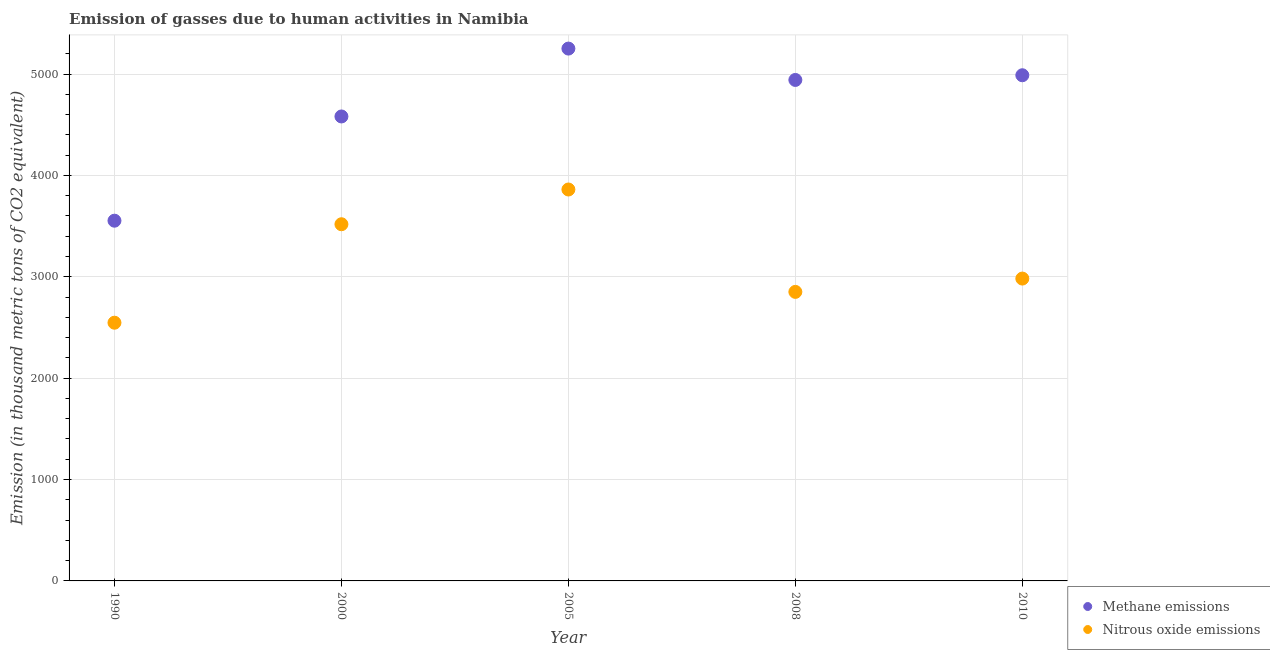How many different coloured dotlines are there?
Your response must be concise. 2. Is the number of dotlines equal to the number of legend labels?
Keep it short and to the point. Yes. What is the amount of nitrous oxide emissions in 2008?
Provide a succinct answer. 2851.2. Across all years, what is the maximum amount of methane emissions?
Your answer should be compact. 5251.3. Across all years, what is the minimum amount of methane emissions?
Offer a very short reply. 3553.5. In which year was the amount of nitrous oxide emissions maximum?
Provide a succinct answer. 2005. In which year was the amount of methane emissions minimum?
Provide a succinct answer. 1990. What is the total amount of methane emissions in the graph?
Give a very brief answer. 2.33e+04. What is the difference between the amount of nitrous oxide emissions in 1990 and that in 2000?
Ensure brevity in your answer.  -971.4. What is the difference between the amount of nitrous oxide emissions in 2000 and the amount of methane emissions in 2005?
Offer a very short reply. -1732.8. What is the average amount of methane emissions per year?
Make the answer very short. 4663.32. In the year 2008, what is the difference between the amount of nitrous oxide emissions and amount of methane emissions?
Offer a terse response. -2090.7. In how many years, is the amount of nitrous oxide emissions greater than 4600 thousand metric tons?
Ensure brevity in your answer.  0. What is the ratio of the amount of methane emissions in 2000 to that in 2008?
Your response must be concise. 0.93. What is the difference between the highest and the second highest amount of methane emissions?
Provide a succinct answer. 263.1. What is the difference between the highest and the lowest amount of nitrous oxide emissions?
Provide a succinct answer. 1314.1. Does the amount of nitrous oxide emissions monotonically increase over the years?
Your response must be concise. No. Is the amount of methane emissions strictly greater than the amount of nitrous oxide emissions over the years?
Make the answer very short. Yes. Is the amount of methane emissions strictly less than the amount of nitrous oxide emissions over the years?
Offer a very short reply. No. How many years are there in the graph?
Keep it short and to the point. 5. Are the values on the major ticks of Y-axis written in scientific E-notation?
Your answer should be compact. No. Does the graph contain any zero values?
Give a very brief answer. No. How many legend labels are there?
Offer a terse response. 2. How are the legend labels stacked?
Keep it short and to the point. Vertical. What is the title of the graph?
Provide a succinct answer. Emission of gasses due to human activities in Namibia. Does "Investments" appear as one of the legend labels in the graph?
Provide a short and direct response. No. What is the label or title of the X-axis?
Give a very brief answer. Year. What is the label or title of the Y-axis?
Ensure brevity in your answer.  Emission (in thousand metric tons of CO2 equivalent). What is the Emission (in thousand metric tons of CO2 equivalent) of Methane emissions in 1990?
Offer a very short reply. 3553.5. What is the Emission (in thousand metric tons of CO2 equivalent) in Nitrous oxide emissions in 1990?
Your answer should be very brief. 2547.1. What is the Emission (in thousand metric tons of CO2 equivalent) of Methane emissions in 2000?
Provide a succinct answer. 4581.7. What is the Emission (in thousand metric tons of CO2 equivalent) of Nitrous oxide emissions in 2000?
Give a very brief answer. 3518.5. What is the Emission (in thousand metric tons of CO2 equivalent) in Methane emissions in 2005?
Keep it short and to the point. 5251.3. What is the Emission (in thousand metric tons of CO2 equivalent) in Nitrous oxide emissions in 2005?
Your response must be concise. 3861.2. What is the Emission (in thousand metric tons of CO2 equivalent) of Methane emissions in 2008?
Offer a terse response. 4941.9. What is the Emission (in thousand metric tons of CO2 equivalent) in Nitrous oxide emissions in 2008?
Provide a short and direct response. 2851.2. What is the Emission (in thousand metric tons of CO2 equivalent) of Methane emissions in 2010?
Your response must be concise. 4988.2. What is the Emission (in thousand metric tons of CO2 equivalent) in Nitrous oxide emissions in 2010?
Your answer should be compact. 2982.6. Across all years, what is the maximum Emission (in thousand metric tons of CO2 equivalent) of Methane emissions?
Keep it short and to the point. 5251.3. Across all years, what is the maximum Emission (in thousand metric tons of CO2 equivalent) in Nitrous oxide emissions?
Your answer should be compact. 3861.2. Across all years, what is the minimum Emission (in thousand metric tons of CO2 equivalent) in Methane emissions?
Keep it short and to the point. 3553.5. Across all years, what is the minimum Emission (in thousand metric tons of CO2 equivalent) of Nitrous oxide emissions?
Offer a very short reply. 2547.1. What is the total Emission (in thousand metric tons of CO2 equivalent) of Methane emissions in the graph?
Your answer should be compact. 2.33e+04. What is the total Emission (in thousand metric tons of CO2 equivalent) of Nitrous oxide emissions in the graph?
Offer a terse response. 1.58e+04. What is the difference between the Emission (in thousand metric tons of CO2 equivalent) of Methane emissions in 1990 and that in 2000?
Provide a short and direct response. -1028.2. What is the difference between the Emission (in thousand metric tons of CO2 equivalent) of Nitrous oxide emissions in 1990 and that in 2000?
Provide a short and direct response. -971.4. What is the difference between the Emission (in thousand metric tons of CO2 equivalent) of Methane emissions in 1990 and that in 2005?
Make the answer very short. -1697.8. What is the difference between the Emission (in thousand metric tons of CO2 equivalent) of Nitrous oxide emissions in 1990 and that in 2005?
Offer a terse response. -1314.1. What is the difference between the Emission (in thousand metric tons of CO2 equivalent) of Methane emissions in 1990 and that in 2008?
Give a very brief answer. -1388.4. What is the difference between the Emission (in thousand metric tons of CO2 equivalent) in Nitrous oxide emissions in 1990 and that in 2008?
Make the answer very short. -304.1. What is the difference between the Emission (in thousand metric tons of CO2 equivalent) of Methane emissions in 1990 and that in 2010?
Provide a succinct answer. -1434.7. What is the difference between the Emission (in thousand metric tons of CO2 equivalent) of Nitrous oxide emissions in 1990 and that in 2010?
Offer a very short reply. -435.5. What is the difference between the Emission (in thousand metric tons of CO2 equivalent) in Methane emissions in 2000 and that in 2005?
Offer a very short reply. -669.6. What is the difference between the Emission (in thousand metric tons of CO2 equivalent) of Nitrous oxide emissions in 2000 and that in 2005?
Give a very brief answer. -342.7. What is the difference between the Emission (in thousand metric tons of CO2 equivalent) in Methane emissions in 2000 and that in 2008?
Your answer should be compact. -360.2. What is the difference between the Emission (in thousand metric tons of CO2 equivalent) in Nitrous oxide emissions in 2000 and that in 2008?
Your response must be concise. 667.3. What is the difference between the Emission (in thousand metric tons of CO2 equivalent) of Methane emissions in 2000 and that in 2010?
Offer a very short reply. -406.5. What is the difference between the Emission (in thousand metric tons of CO2 equivalent) in Nitrous oxide emissions in 2000 and that in 2010?
Give a very brief answer. 535.9. What is the difference between the Emission (in thousand metric tons of CO2 equivalent) in Methane emissions in 2005 and that in 2008?
Your answer should be compact. 309.4. What is the difference between the Emission (in thousand metric tons of CO2 equivalent) of Nitrous oxide emissions in 2005 and that in 2008?
Offer a very short reply. 1010. What is the difference between the Emission (in thousand metric tons of CO2 equivalent) of Methane emissions in 2005 and that in 2010?
Your answer should be compact. 263.1. What is the difference between the Emission (in thousand metric tons of CO2 equivalent) in Nitrous oxide emissions in 2005 and that in 2010?
Keep it short and to the point. 878.6. What is the difference between the Emission (in thousand metric tons of CO2 equivalent) in Methane emissions in 2008 and that in 2010?
Make the answer very short. -46.3. What is the difference between the Emission (in thousand metric tons of CO2 equivalent) of Nitrous oxide emissions in 2008 and that in 2010?
Offer a very short reply. -131.4. What is the difference between the Emission (in thousand metric tons of CO2 equivalent) in Methane emissions in 1990 and the Emission (in thousand metric tons of CO2 equivalent) in Nitrous oxide emissions in 2005?
Provide a short and direct response. -307.7. What is the difference between the Emission (in thousand metric tons of CO2 equivalent) of Methane emissions in 1990 and the Emission (in thousand metric tons of CO2 equivalent) of Nitrous oxide emissions in 2008?
Ensure brevity in your answer.  702.3. What is the difference between the Emission (in thousand metric tons of CO2 equivalent) in Methane emissions in 1990 and the Emission (in thousand metric tons of CO2 equivalent) in Nitrous oxide emissions in 2010?
Ensure brevity in your answer.  570.9. What is the difference between the Emission (in thousand metric tons of CO2 equivalent) of Methane emissions in 2000 and the Emission (in thousand metric tons of CO2 equivalent) of Nitrous oxide emissions in 2005?
Your response must be concise. 720.5. What is the difference between the Emission (in thousand metric tons of CO2 equivalent) in Methane emissions in 2000 and the Emission (in thousand metric tons of CO2 equivalent) in Nitrous oxide emissions in 2008?
Provide a succinct answer. 1730.5. What is the difference between the Emission (in thousand metric tons of CO2 equivalent) in Methane emissions in 2000 and the Emission (in thousand metric tons of CO2 equivalent) in Nitrous oxide emissions in 2010?
Your answer should be compact. 1599.1. What is the difference between the Emission (in thousand metric tons of CO2 equivalent) of Methane emissions in 2005 and the Emission (in thousand metric tons of CO2 equivalent) of Nitrous oxide emissions in 2008?
Provide a short and direct response. 2400.1. What is the difference between the Emission (in thousand metric tons of CO2 equivalent) in Methane emissions in 2005 and the Emission (in thousand metric tons of CO2 equivalent) in Nitrous oxide emissions in 2010?
Your answer should be compact. 2268.7. What is the difference between the Emission (in thousand metric tons of CO2 equivalent) in Methane emissions in 2008 and the Emission (in thousand metric tons of CO2 equivalent) in Nitrous oxide emissions in 2010?
Your answer should be compact. 1959.3. What is the average Emission (in thousand metric tons of CO2 equivalent) in Methane emissions per year?
Your answer should be compact. 4663.32. What is the average Emission (in thousand metric tons of CO2 equivalent) in Nitrous oxide emissions per year?
Ensure brevity in your answer.  3152.12. In the year 1990, what is the difference between the Emission (in thousand metric tons of CO2 equivalent) of Methane emissions and Emission (in thousand metric tons of CO2 equivalent) of Nitrous oxide emissions?
Ensure brevity in your answer.  1006.4. In the year 2000, what is the difference between the Emission (in thousand metric tons of CO2 equivalent) in Methane emissions and Emission (in thousand metric tons of CO2 equivalent) in Nitrous oxide emissions?
Give a very brief answer. 1063.2. In the year 2005, what is the difference between the Emission (in thousand metric tons of CO2 equivalent) in Methane emissions and Emission (in thousand metric tons of CO2 equivalent) in Nitrous oxide emissions?
Ensure brevity in your answer.  1390.1. In the year 2008, what is the difference between the Emission (in thousand metric tons of CO2 equivalent) in Methane emissions and Emission (in thousand metric tons of CO2 equivalent) in Nitrous oxide emissions?
Keep it short and to the point. 2090.7. In the year 2010, what is the difference between the Emission (in thousand metric tons of CO2 equivalent) of Methane emissions and Emission (in thousand metric tons of CO2 equivalent) of Nitrous oxide emissions?
Offer a terse response. 2005.6. What is the ratio of the Emission (in thousand metric tons of CO2 equivalent) in Methane emissions in 1990 to that in 2000?
Give a very brief answer. 0.78. What is the ratio of the Emission (in thousand metric tons of CO2 equivalent) of Nitrous oxide emissions in 1990 to that in 2000?
Give a very brief answer. 0.72. What is the ratio of the Emission (in thousand metric tons of CO2 equivalent) of Methane emissions in 1990 to that in 2005?
Provide a succinct answer. 0.68. What is the ratio of the Emission (in thousand metric tons of CO2 equivalent) in Nitrous oxide emissions in 1990 to that in 2005?
Make the answer very short. 0.66. What is the ratio of the Emission (in thousand metric tons of CO2 equivalent) in Methane emissions in 1990 to that in 2008?
Your response must be concise. 0.72. What is the ratio of the Emission (in thousand metric tons of CO2 equivalent) in Nitrous oxide emissions in 1990 to that in 2008?
Your answer should be very brief. 0.89. What is the ratio of the Emission (in thousand metric tons of CO2 equivalent) in Methane emissions in 1990 to that in 2010?
Your response must be concise. 0.71. What is the ratio of the Emission (in thousand metric tons of CO2 equivalent) in Nitrous oxide emissions in 1990 to that in 2010?
Your response must be concise. 0.85. What is the ratio of the Emission (in thousand metric tons of CO2 equivalent) in Methane emissions in 2000 to that in 2005?
Ensure brevity in your answer.  0.87. What is the ratio of the Emission (in thousand metric tons of CO2 equivalent) in Nitrous oxide emissions in 2000 to that in 2005?
Your answer should be very brief. 0.91. What is the ratio of the Emission (in thousand metric tons of CO2 equivalent) in Methane emissions in 2000 to that in 2008?
Your response must be concise. 0.93. What is the ratio of the Emission (in thousand metric tons of CO2 equivalent) in Nitrous oxide emissions in 2000 to that in 2008?
Ensure brevity in your answer.  1.23. What is the ratio of the Emission (in thousand metric tons of CO2 equivalent) in Methane emissions in 2000 to that in 2010?
Your answer should be very brief. 0.92. What is the ratio of the Emission (in thousand metric tons of CO2 equivalent) in Nitrous oxide emissions in 2000 to that in 2010?
Offer a terse response. 1.18. What is the ratio of the Emission (in thousand metric tons of CO2 equivalent) of Methane emissions in 2005 to that in 2008?
Ensure brevity in your answer.  1.06. What is the ratio of the Emission (in thousand metric tons of CO2 equivalent) in Nitrous oxide emissions in 2005 to that in 2008?
Give a very brief answer. 1.35. What is the ratio of the Emission (in thousand metric tons of CO2 equivalent) in Methane emissions in 2005 to that in 2010?
Your answer should be very brief. 1.05. What is the ratio of the Emission (in thousand metric tons of CO2 equivalent) in Nitrous oxide emissions in 2005 to that in 2010?
Keep it short and to the point. 1.29. What is the ratio of the Emission (in thousand metric tons of CO2 equivalent) in Nitrous oxide emissions in 2008 to that in 2010?
Ensure brevity in your answer.  0.96. What is the difference between the highest and the second highest Emission (in thousand metric tons of CO2 equivalent) in Methane emissions?
Provide a short and direct response. 263.1. What is the difference between the highest and the second highest Emission (in thousand metric tons of CO2 equivalent) of Nitrous oxide emissions?
Provide a succinct answer. 342.7. What is the difference between the highest and the lowest Emission (in thousand metric tons of CO2 equivalent) in Methane emissions?
Your answer should be very brief. 1697.8. What is the difference between the highest and the lowest Emission (in thousand metric tons of CO2 equivalent) in Nitrous oxide emissions?
Give a very brief answer. 1314.1. 